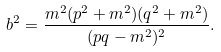Convert formula to latex. <formula><loc_0><loc_0><loc_500><loc_500>b ^ { 2 } = \frac { m ^ { 2 } ( p ^ { 2 } + m ^ { 2 } ) ( q ^ { 2 } + m ^ { 2 } ) } { ( p q - m ^ { 2 } ) ^ { 2 } } .</formula> 